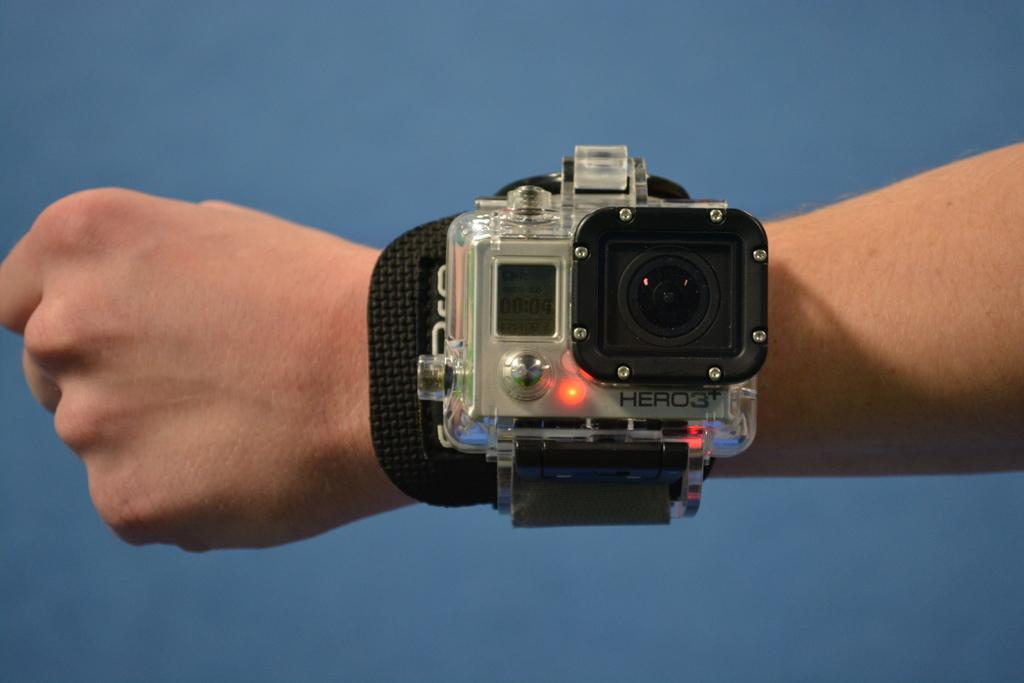What is on the person's hand in the image? A camera is visible on the hand. What can be inferred about the person's activity based on the presence of the camera? The person might be taking a picture or recording a video. What is the color of the background in the image? The background of the image has a blue color. What is the weight of the idea being discussed in the image? There is no discussion or idea present in the image; it only shows a person's hand with a camera and a blue background. 